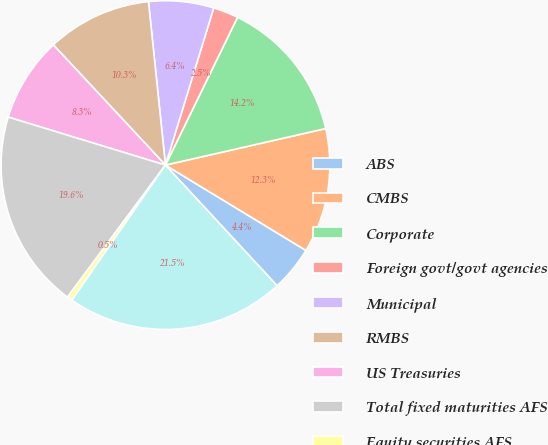Convert chart to OTSL. <chart><loc_0><loc_0><loc_500><loc_500><pie_chart><fcel>ABS<fcel>CMBS<fcel>Corporate<fcel>Foreign govt/govt agencies<fcel>Municipal<fcel>RMBS<fcel>US Treasuries<fcel>Total fixed maturities AFS<fcel>Equity securities AFS<fcel>Total securities in an<nl><fcel>4.43%<fcel>12.26%<fcel>14.21%<fcel>2.48%<fcel>6.39%<fcel>10.3%<fcel>8.34%<fcel>19.56%<fcel>0.52%<fcel>21.52%<nl></chart> 